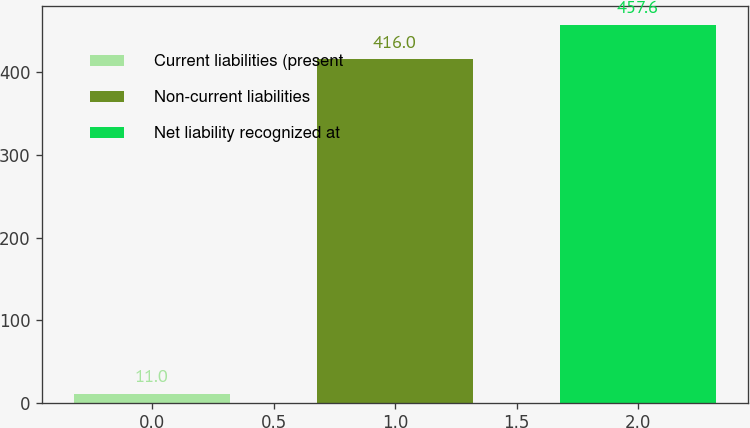<chart> <loc_0><loc_0><loc_500><loc_500><bar_chart><fcel>Current liabilities (present<fcel>Non-current liabilities<fcel>Net liability recognized at<nl><fcel>11<fcel>416<fcel>457.6<nl></chart> 